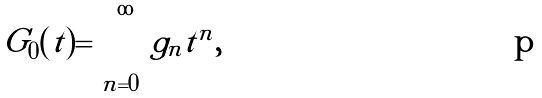<formula> <loc_0><loc_0><loc_500><loc_500>G _ { 0 } ( t ) = \sum _ { n = 0 } ^ { \infty } g _ { n } t ^ { n } ,</formula> 